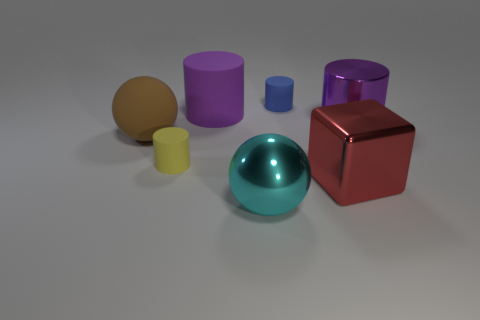What size is the ball that is right of the large purple cylinder behind the object right of the big red thing?
Ensure brevity in your answer.  Large. Does the tiny yellow object have the same shape as the tiny matte thing behind the brown rubber ball?
Your response must be concise. Yes. How many big things are both to the right of the purple matte cylinder and behind the big cube?
Keep it short and to the point. 1. What number of cyan things are either metallic cylinders or big objects?
Keep it short and to the point. 1. There is a large cylinder that is on the left side of the big cyan ball; is it the same color as the large cylinder right of the large cyan metallic object?
Make the answer very short. Yes. What color is the big matte object behind the big sphere behind the thing that is in front of the large red thing?
Your response must be concise. Purple. Is there a small cylinder behind the big sphere that is left of the cyan object?
Offer a very short reply. Yes. There is a big matte thing behind the brown sphere; is it the same shape as the cyan shiny object?
Your answer should be very brief. No. Is there anything else that has the same shape as the big red thing?
Offer a very short reply. No. How many spheres are big shiny things or tiny blue objects?
Your answer should be very brief. 1. 